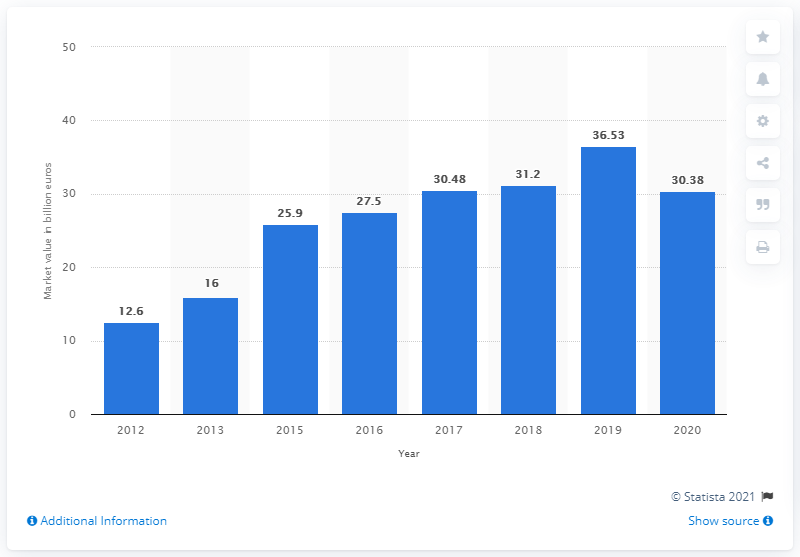Point out several critical features in this image. In 2020, the global market for personal luxury goods was worth approximately 30.38 billion US dollars. 